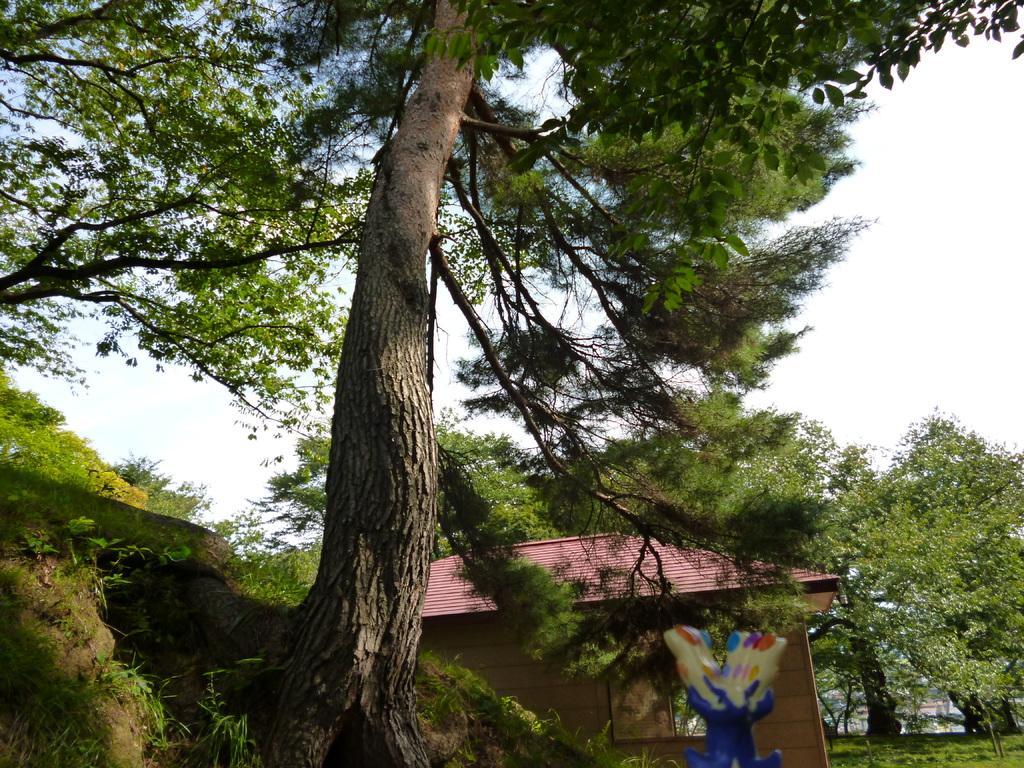Can you describe this image briefly? In the center of the image we can see trees, house, hills, grass are present. At the bottom of the image ground is there. At the top of the image sky is there. 